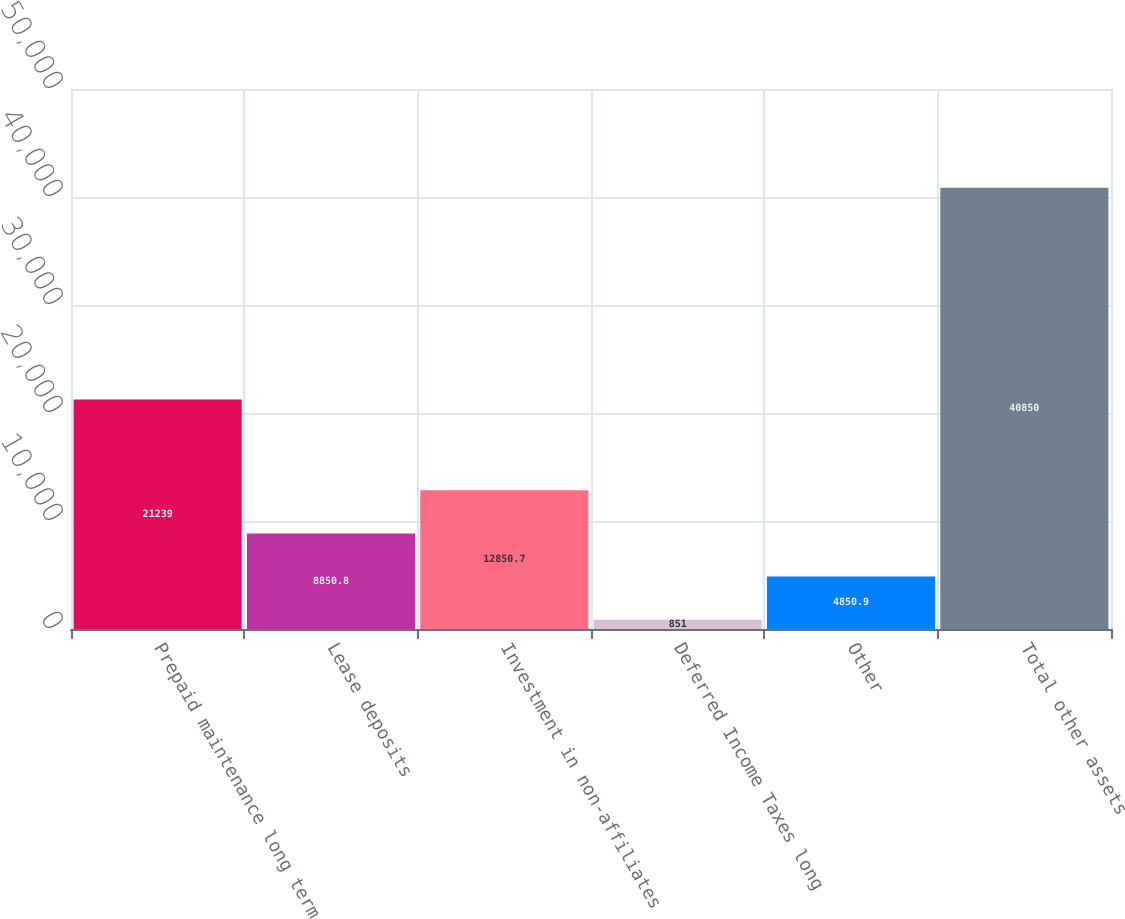Convert chart. <chart><loc_0><loc_0><loc_500><loc_500><bar_chart><fcel>Prepaid maintenance long term<fcel>Lease deposits<fcel>Investment in non-affiliates<fcel>Deferred Income Taxes long<fcel>Other<fcel>Total other assets<nl><fcel>21239<fcel>8850.8<fcel>12850.7<fcel>851<fcel>4850.9<fcel>40850<nl></chart> 